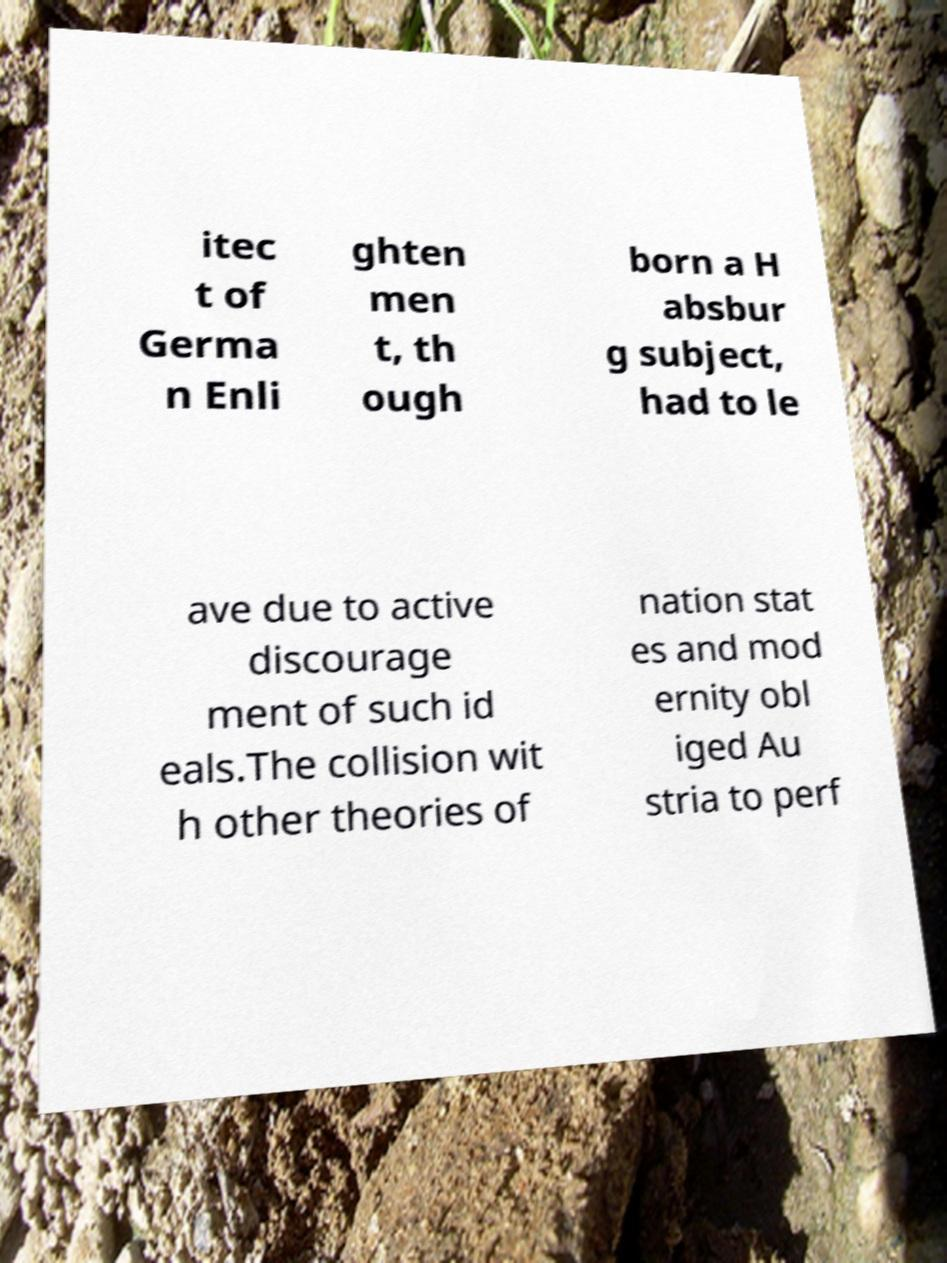Please identify and transcribe the text found in this image. itec t of Germa n Enli ghten men t, th ough born a H absbur g subject, had to le ave due to active discourage ment of such id eals.The collision wit h other theories of nation stat es and mod ernity obl iged Au stria to perf 